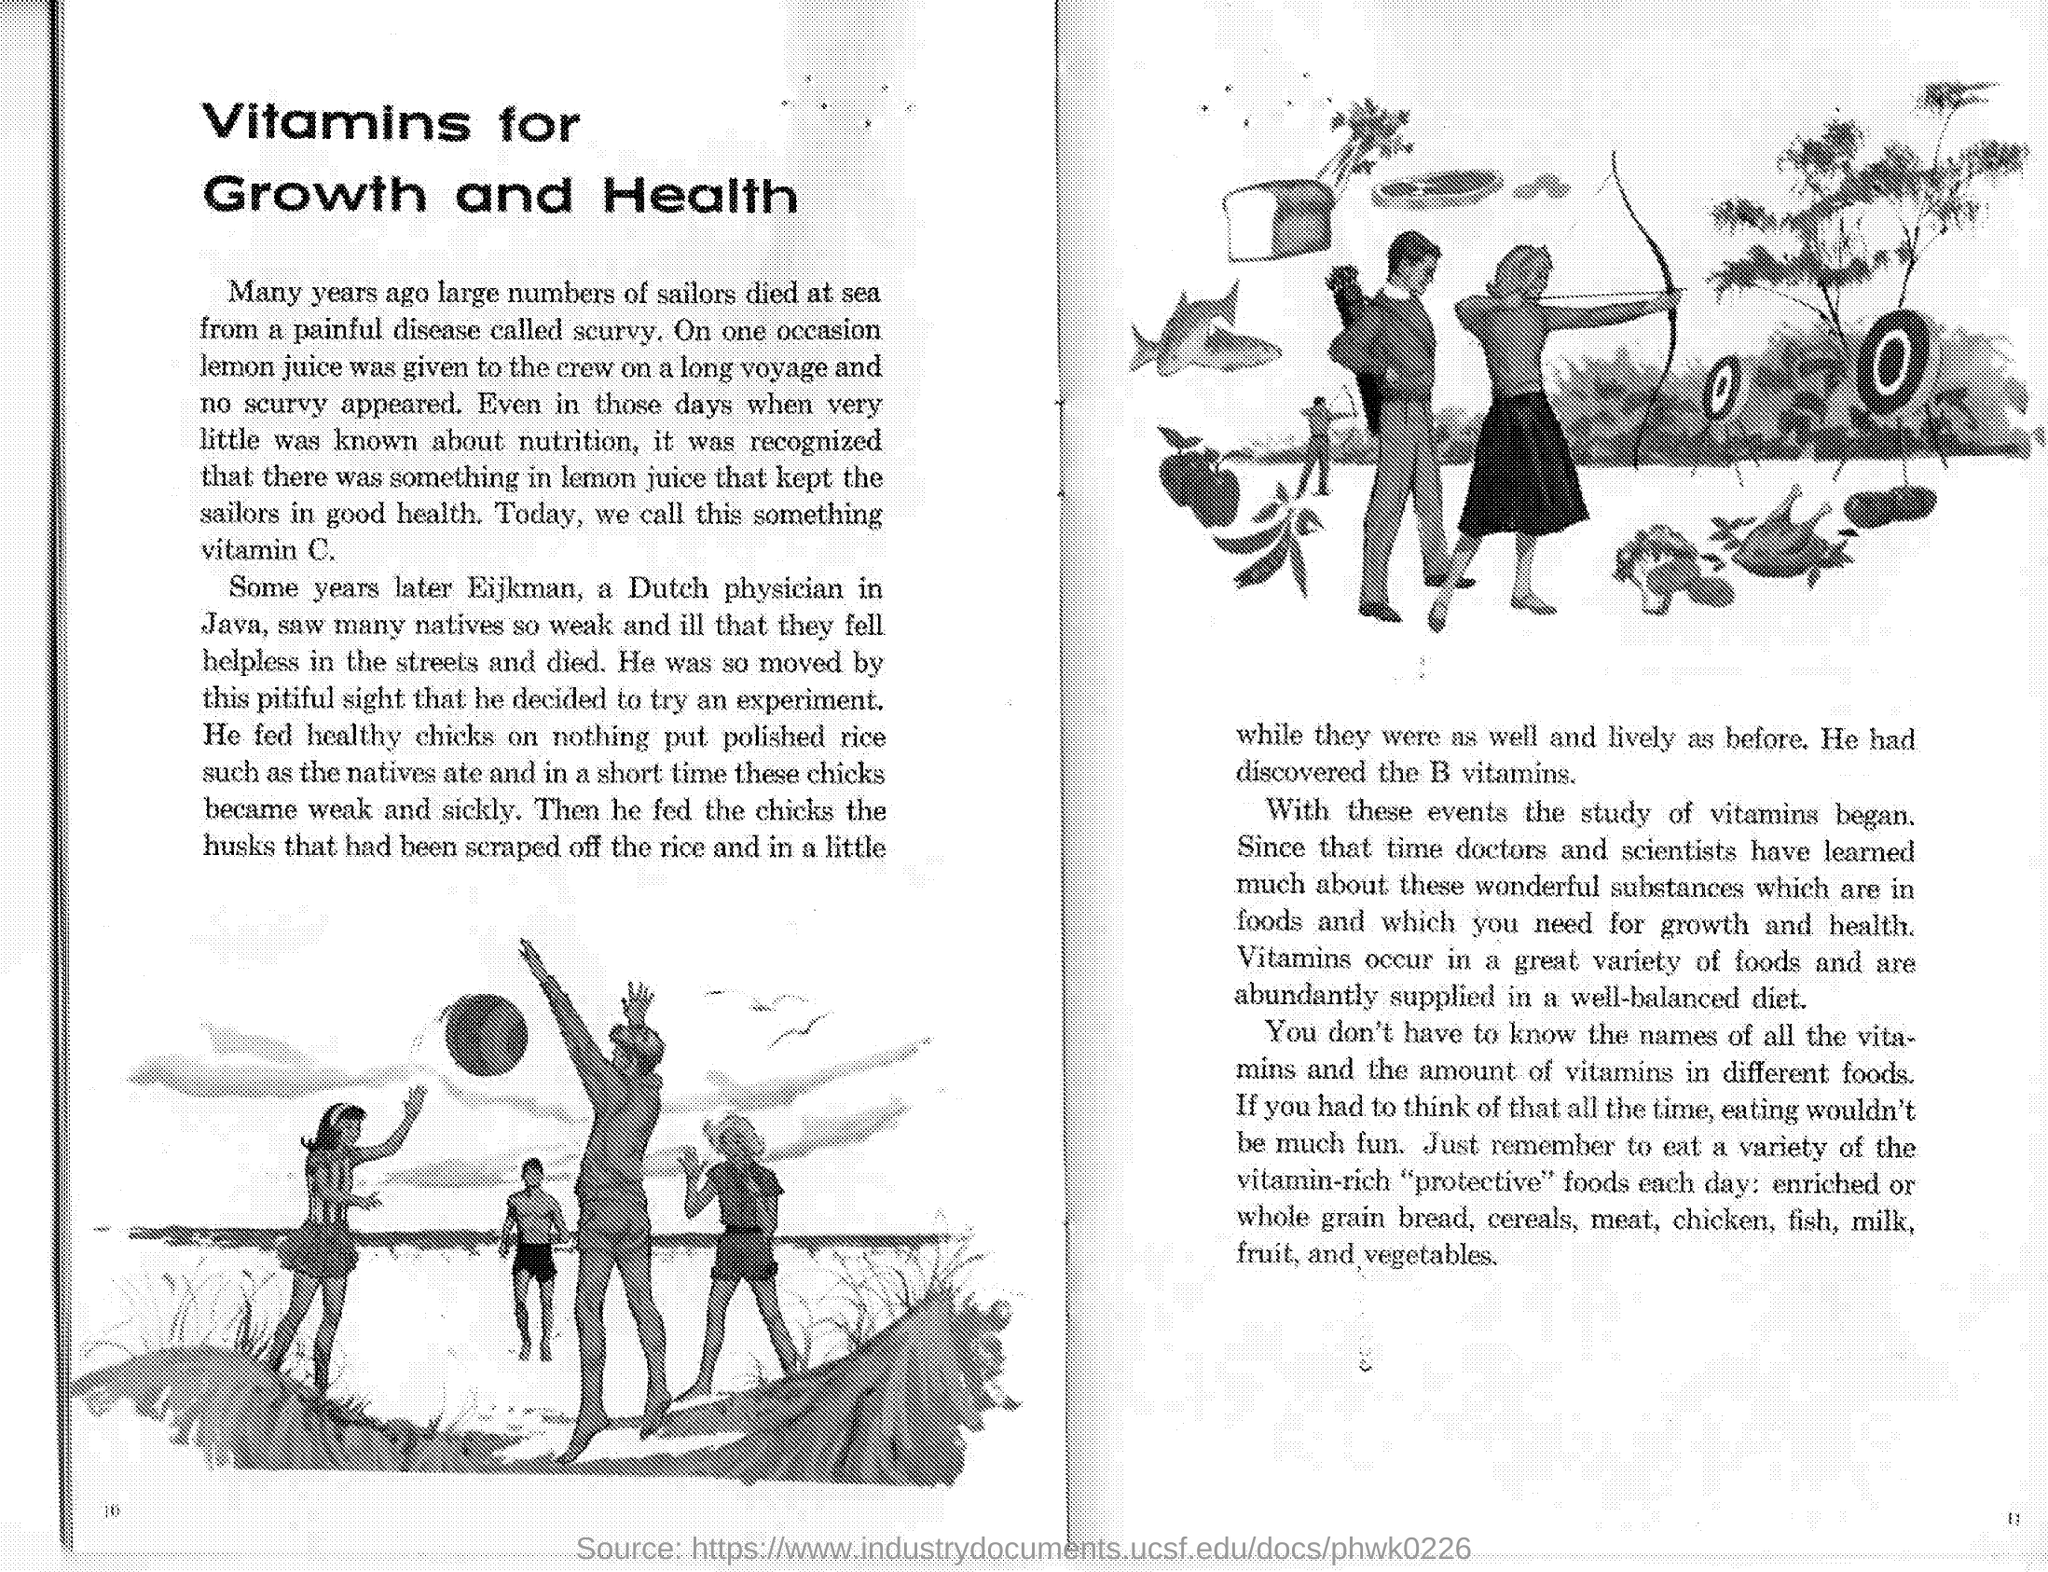What disease did sailors at sea have many years ago?
Your response must be concise. Scurvy. What is the vitamin present in lemon juice?
Your answer should be very brief. Vitamin c. Which Dutch physician experimented on the condition of people in Java?
Your response must be concise. Eijkman. Which Vitamin did Eijkman discover?
Keep it short and to the point. B vitamins. 